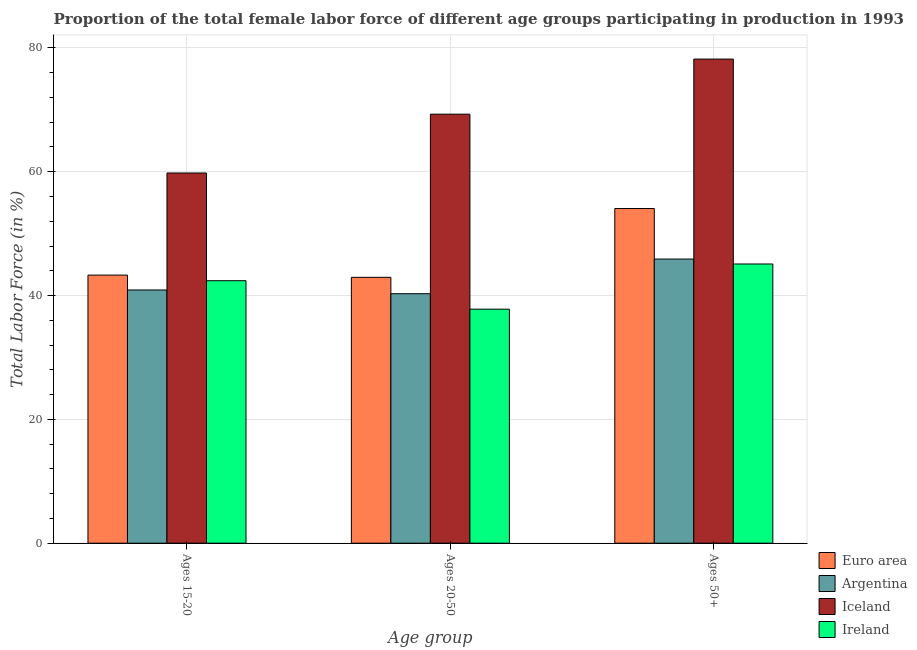How many groups of bars are there?
Make the answer very short. 3. Are the number of bars on each tick of the X-axis equal?
Offer a terse response. Yes. How many bars are there on the 1st tick from the left?
Your answer should be compact. 4. How many bars are there on the 2nd tick from the right?
Give a very brief answer. 4. What is the label of the 1st group of bars from the left?
Your answer should be compact. Ages 15-20. What is the percentage of female labor force above age 50 in Euro area?
Make the answer very short. 54.06. Across all countries, what is the maximum percentage of female labor force within the age group 20-50?
Provide a short and direct response. 69.3. Across all countries, what is the minimum percentage of female labor force within the age group 15-20?
Provide a succinct answer. 40.9. In which country was the percentage of female labor force within the age group 15-20 minimum?
Keep it short and to the point. Argentina. What is the total percentage of female labor force above age 50 in the graph?
Provide a succinct answer. 223.26. What is the difference between the percentage of female labor force within the age group 20-50 in Ireland and that in Iceland?
Your answer should be very brief. -31.5. What is the difference between the percentage of female labor force above age 50 in Argentina and the percentage of female labor force within the age group 15-20 in Iceland?
Provide a succinct answer. -13.9. What is the average percentage of female labor force above age 50 per country?
Keep it short and to the point. 55.82. What is the difference between the percentage of female labor force within the age group 20-50 and percentage of female labor force above age 50 in Euro area?
Offer a terse response. -11.11. What is the ratio of the percentage of female labor force within the age group 20-50 in Iceland to that in Euro area?
Provide a succinct answer. 1.61. Is the percentage of female labor force within the age group 15-20 in Euro area less than that in Iceland?
Provide a short and direct response. Yes. Is the difference between the percentage of female labor force within the age group 20-50 in Ireland and Iceland greater than the difference between the percentage of female labor force above age 50 in Ireland and Iceland?
Keep it short and to the point. Yes. What is the difference between the highest and the second highest percentage of female labor force within the age group 20-50?
Ensure brevity in your answer.  26.35. What is the difference between the highest and the lowest percentage of female labor force above age 50?
Offer a terse response. 33.1. Is the sum of the percentage of female labor force within the age group 15-20 in Argentina and Iceland greater than the maximum percentage of female labor force within the age group 20-50 across all countries?
Offer a very short reply. Yes. How many countries are there in the graph?
Give a very brief answer. 4. Are the values on the major ticks of Y-axis written in scientific E-notation?
Ensure brevity in your answer.  No. What is the title of the graph?
Your response must be concise. Proportion of the total female labor force of different age groups participating in production in 1993. What is the label or title of the X-axis?
Offer a terse response. Age group. What is the label or title of the Y-axis?
Provide a succinct answer. Total Labor Force (in %). What is the Total Labor Force (in %) of Euro area in Ages 15-20?
Make the answer very short. 43.31. What is the Total Labor Force (in %) of Argentina in Ages 15-20?
Give a very brief answer. 40.9. What is the Total Labor Force (in %) in Iceland in Ages 15-20?
Ensure brevity in your answer.  59.8. What is the Total Labor Force (in %) of Ireland in Ages 15-20?
Offer a very short reply. 42.4. What is the Total Labor Force (in %) in Euro area in Ages 20-50?
Make the answer very short. 42.95. What is the Total Labor Force (in %) in Argentina in Ages 20-50?
Your answer should be compact. 40.3. What is the Total Labor Force (in %) of Iceland in Ages 20-50?
Your answer should be compact. 69.3. What is the Total Labor Force (in %) of Ireland in Ages 20-50?
Your response must be concise. 37.8. What is the Total Labor Force (in %) in Euro area in Ages 50+?
Provide a short and direct response. 54.06. What is the Total Labor Force (in %) in Argentina in Ages 50+?
Your answer should be compact. 45.9. What is the Total Labor Force (in %) in Iceland in Ages 50+?
Ensure brevity in your answer.  78.2. What is the Total Labor Force (in %) in Ireland in Ages 50+?
Give a very brief answer. 45.1. Across all Age group, what is the maximum Total Labor Force (in %) in Euro area?
Provide a short and direct response. 54.06. Across all Age group, what is the maximum Total Labor Force (in %) in Argentina?
Your response must be concise. 45.9. Across all Age group, what is the maximum Total Labor Force (in %) of Iceland?
Your response must be concise. 78.2. Across all Age group, what is the maximum Total Labor Force (in %) of Ireland?
Keep it short and to the point. 45.1. Across all Age group, what is the minimum Total Labor Force (in %) of Euro area?
Give a very brief answer. 42.95. Across all Age group, what is the minimum Total Labor Force (in %) in Argentina?
Make the answer very short. 40.3. Across all Age group, what is the minimum Total Labor Force (in %) of Iceland?
Provide a short and direct response. 59.8. Across all Age group, what is the minimum Total Labor Force (in %) of Ireland?
Offer a very short reply. 37.8. What is the total Total Labor Force (in %) in Euro area in the graph?
Your answer should be very brief. 140.31. What is the total Total Labor Force (in %) of Argentina in the graph?
Make the answer very short. 127.1. What is the total Total Labor Force (in %) in Iceland in the graph?
Keep it short and to the point. 207.3. What is the total Total Labor Force (in %) in Ireland in the graph?
Keep it short and to the point. 125.3. What is the difference between the Total Labor Force (in %) in Euro area in Ages 15-20 and that in Ages 20-50?
Offer a terse response. 0.36. What is the difference between the Total Labor Force (in %) in Argentina in Ages 15-20 and that in Ages 20-50?
Offer a very short reply. 0.6. What is the difference between the Total Labor Force (in %) of Iceland in Ages 15-20 and that in Ages 20-50?
Provide a succinct answer. -9.5. What is the difference between the Total Labor Force (in %) in Ireland in Ages 15-20 and that in Ages 20-50?
Your answer should be very brief. 4.6. What is the difference between the Total Labor Force (in %) of Euro area in Ages 15-20 and that in Ages 50+?
Provide a succinct answer. -10.75. What is the difference between the Total Labor Force (in %) in Iceland in Ages 15-20 and that in Ages 50+?
Your answer should be compact. -18.4. What is the difference between the Total Labor Force (in %) in Euro area in Ages 20-50 and that in Ages 50+?
Give a very brief answer. -11.11. What is the difference between the Total Labor Force (in %) of Iceland in Ages 20-50 and that in Ages 50+?
Ensure brevity in your answer.  -8.9. What is the difference between the Total Labor Force (in %) of Ireland in Ages 20-50 and that in Ages 50+?
Your response must be concise. -7.3. What is the difference between the Total Labor Force (in %) of Euro area in Ages 15-20 and the Total Labor Force (in %) of Argentina in Ages 20-50?
Your response must be concise. 3.01. What is the difference between the Total Labor Force (in %) of Euro area in Ages 15-20 and the Total Labor Force (in %) of Iceland in Ages 20-50?
Your answer should be very brief. -25.99. What is the difference between the Total Labor Force (in %) in Euro area in Ages 15-20 and the Total Labor Force (in %) in Ireland in Ages 20-50?
Give a very brief answer. 5.51. What is the difference between the Total Labor Force (in %) of Argentina in Ages 15-20 and the Total Labor Force (in %) of Iceland in Ages 20-50?
Provide a short and direct response. -28.4. What is the difference between the Total Labor Force (in %) in Iceland in Ages 15-20 and the Total Labor Force (in %) in Ireland in Ages 20-50?
Offer a very short reply. 22. What is the difference between the Total Labor Force (in %) of Euro area in Ages 15-20 and the Total Labor Force (in %) of Argentina in Ages 50+?
Give a very brief answer. -2.59. What is the difference between the Total Labor Force (in %) in Euro area in Ages 15-20 and the Total Labor Force (in %) in Iceland in Ages 50+?
Provide a succinct answer. -34.89. What is the difference between the Total Labor Force (in %) of Euro area in Ages 15-20 and the Total Labor Force (in %) of Ireland in Ages 50+?
Give a very brief answer. -1.79. What is the difference between the Total Labor Force (in %) of Argentina in Ages 15-20 and the Total Labor Force (in %) of Iceland in Ages 50+?
Provide a succinct answer. -37.3. What is the difference between the Total Labor Force (in %) of Argentina in Ages 15-20 and the Total Labor Force (in %) of Ireland in Ages 50+?
Offer a very short reply. -4.2. What is the difference between the Total Labor Force (in %) of Euro area in Ages 20-50 and the Total Labor Force (in %) of Argentina in Ages 50+?
Offer a very short reply. -2.95. What is the difference between the Total Labor Force (in %) in Euro area in Ages 20-50 and the Total Labor Force (in %) in Iceland in Ages 50+?
Provide a short and direct response. -35.25. What is the difference between the Total Labor Force (in %) in Euro area in Ages 20-50 and the Total Labor Force (in %) in Ireland in Ages 50+?
Give a very brief answer. -2.15. What is the difference between the Total Labor Force (in %) in Argentina in Ages 20-50 and the Total Labor Force (in %) in Iceland in Ages 50+?
Ensure brevity in your answer.  -37.9. What is the difference between the Total Labor Force (in %) in Iceland in Ages 20-50 and the Total Labor Force (in %) in Ireland in Ages 50+?
Give a very brief answer. 24.2. What is the average Total Labor Force (in %) of Euro area per Age group?
Give a very brief answer. 46.77. What is the average Total Labor Force (in %) of Argentina per Age group?
Ensure brevity in your answer.  42.37. What is the average Total Labor Force (in %) in Iceland per Age group?
Offer a terse response. 69.1. What is the average Total Labor Force (in %) in Ireland per Age group?
Offer a very short reply. 41.77. What is the difference between the Total Labor Force (in %) of Euro area and Total Labor Force (in %) of Argentina in Ages 15-20?
Your answer should be compact. 2.41. What is the difference between the Total Labor Force (in %) of Euro area and Total Labor Force (in %) of Iceland in Ages 15-20?
Make the answer very short. -16.49. What is the difference between the Total Labor Force (in %) of Euro area and Total Labor Force (in %) of Ireland in Ages 15-20?
Offer a terse response. 0.91. What is the difference between the Total Labor Force (in %) of Argentina and Total Labor Force (in %) of Iceland in Ages 15-20?
Your answer should be very brief. -18.9. What is the difference between the Total Labor Force (in %) of Iceland and Total Labor Force (in %) of Ireland in Ages 15-20?
Provide a short and direct response. 17.4. What is the difference between the Total Labor Force (in %) of Euro area and Total Labor Force (in %) of Argentina in Ages 20-50?
Offer a terse response. 2.65. What is the difference between the Total Labor Force (in %) of Euro area and Total Labor Force (in %) of Iceland in Ages 20-50?
Keep it short and to the point. -26.35. What is the difference between the Total Labor Force (in %) in Euro area and Total Labor Force (in %) in Ireland in Ages 20-50?
Make the answer very short. 5.15. What is the difference between the Total Labor Force (in %) of Argentina and Total Labor Force (in %) of Ireland in Ages 20-50?
Your answer should be compact. 2.5. What is the difference between the Total Labor Force (in %) in Iceland and Total Labor Force (in %) in Ireland in Ages 20-50?
Keep it short and to the point. 31.5. What is the difference between the Total Labor Force (in %) in Euro area and Total Labor Force (in %) in Argentina in Ages 50+?
Offer a very short reply. 8.16. What is the difference between the Total Labor Force (in %) in Euro area and Total Labor Force (in %) in Iceland in Ages 50+?
Keep it short and to the point. -24.14. What is the difference between the Total Labor Force (in %) in Euro area and Total Labor Force (in %) in Ireland in Ages 50+?
Ensure brevity in your answer.  8.96. What is the difference between the Total Labor Force (in %) in Argentina and Total Labor Force (in %) in Iceland in Ages 50+?
Your answer should be compact. -32.3. What is the difference between the Total Labor Force (in %) of Iceland and Total Labor Force (in %) of Ireland in Ages 50+?
Ensure brevity in your answer.  33.1. What is the ratio of the Total Labor Force (in %) of Euro area in Ages 15-20 to that in Ages 20-50?
Your answer should be compact. 1.01. What is the ratio of the Total Labor Force (in %) of Argentina in Ages 15-20 to that in Ages 20-50?
Your answer should be compact. 1.01. What is the ratio of the Total Labor Force (in %) in Iceland in Ages 15-20 to that in Ages 20-50?
Ensure brevity in your answer.  0.86. What is the ratio of the Total Labor Force (in %) in Ireland in Ages 15-20 to that in Ages 20-50?
Your answer should be very brief. 1.12. What is the ratio of the Total Labor Force (in %) in Euro area in Ages 15-20 to that in Ages 50+?
Offer a terse response. 0.8. What is the ratio of the Total Labor Force (in %) in Argentina in Ages 15-20 to that in Ages 50+?
Your response must be concise. 0.89. What is the ratio of the Total Labor Force (in %) in Iceland in Ages 15-20 to that in Ages 50+?
Your answer should be very brief. 0.76. What is the ratio of the Total Labor Force (in %) of Ireland in Ages 15-20 to that in Ages 50+?
Keep it short and to the point. 0.94. What is the ratio of the Total Labor Force (in %) of Euro area in Ages 20-50 to that in Ages 50+?
Ensure brevity in your answer.  0.79. What is the ratio of the Total Labor Force (in %) in Argentina in Ages 20-50 to that in Ages 50+?
Your response must be concise. 0.88. What is the ratio of the Total Labor Force (in %) in Iceland in Ages 20-50 to that in Ages 50+?
Ensure brevity in your answer.  0.89. What is the ratio of the Total Labor Force (in %) in Ireland in Ages 20-50 to that in Ages 50+?
Offer a very short reply. 0.84. What is the difference between the highest and the second highest Total Labor Force (in %) of Euro area?
Offer a terse response. 10.75. What is the difference between the highest and the second highest Total Labor Force (in %) of Argentina?
Offer a very short reply. 5. What is the difference between the highest and the second highest Total Labor Force (in %) in Ireland?
Provide a short and direct response. 2.7. What is the difference between the highest and the lowest Total Labor Force (in %) in Euro area?
Give a very brief answer. 11.11. What is the difference between the highest and the lowest Total Labor Force (in %) in Argentina?
Provide a succinct answer. 5.6. What is the difference between the highest and the lowest Total Labor Force (in %) of Iceland?
Offer a very short reply. 18.4. What is the difference between the highest and the lowest Total Labor Force (in %) of Ireland?
Make the answer very short. 7.3. 